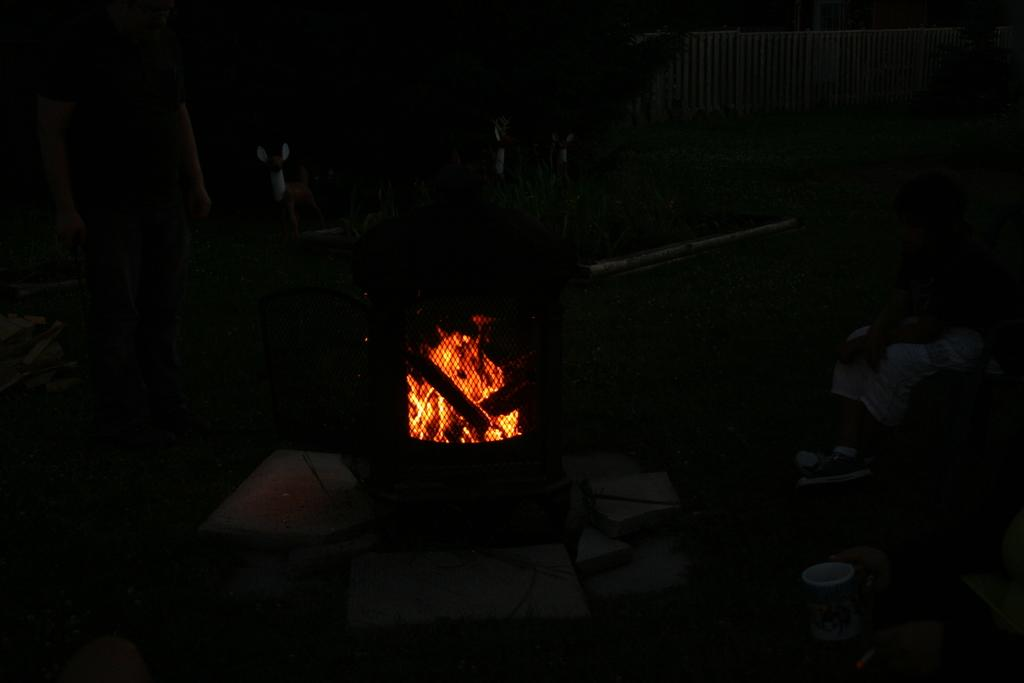What type of stove is visible in the image? There is a wood burning stove in the image. What is the source of heat in the image? There is fire in the image. How would you describe the lighting conditions in the image? The background of the image is dark. What type of letter can be seen on the wall in the image? There is no letter present on the wall in the image. Where is the lamp located in the image? There is no lamp present in the image. 